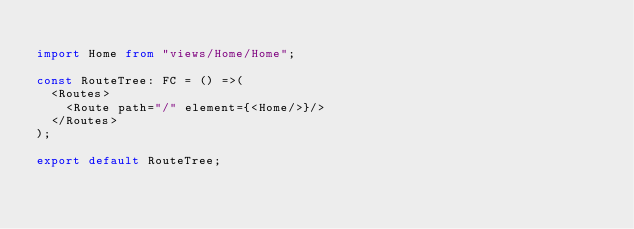<code> <loc_0><loc_0><loc_500><loc_500><_TypeScript_>
import Home from "views/Home/Home";

const RouteTree: FC = () =>(
  <Routes>
    <Route path="/" element={<Home/>}/>
  </Routes>
);

export default RouteTree;
</code> 